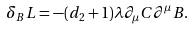Convert formula to latex. <formula><loc_0><loc_0><loc_500><loc_500>\delta _ { B } L = - ( d _ { 2 } + 1 ) \lambda \partial _ { \mu } C \partial ^ { \mu } B .</formula> 